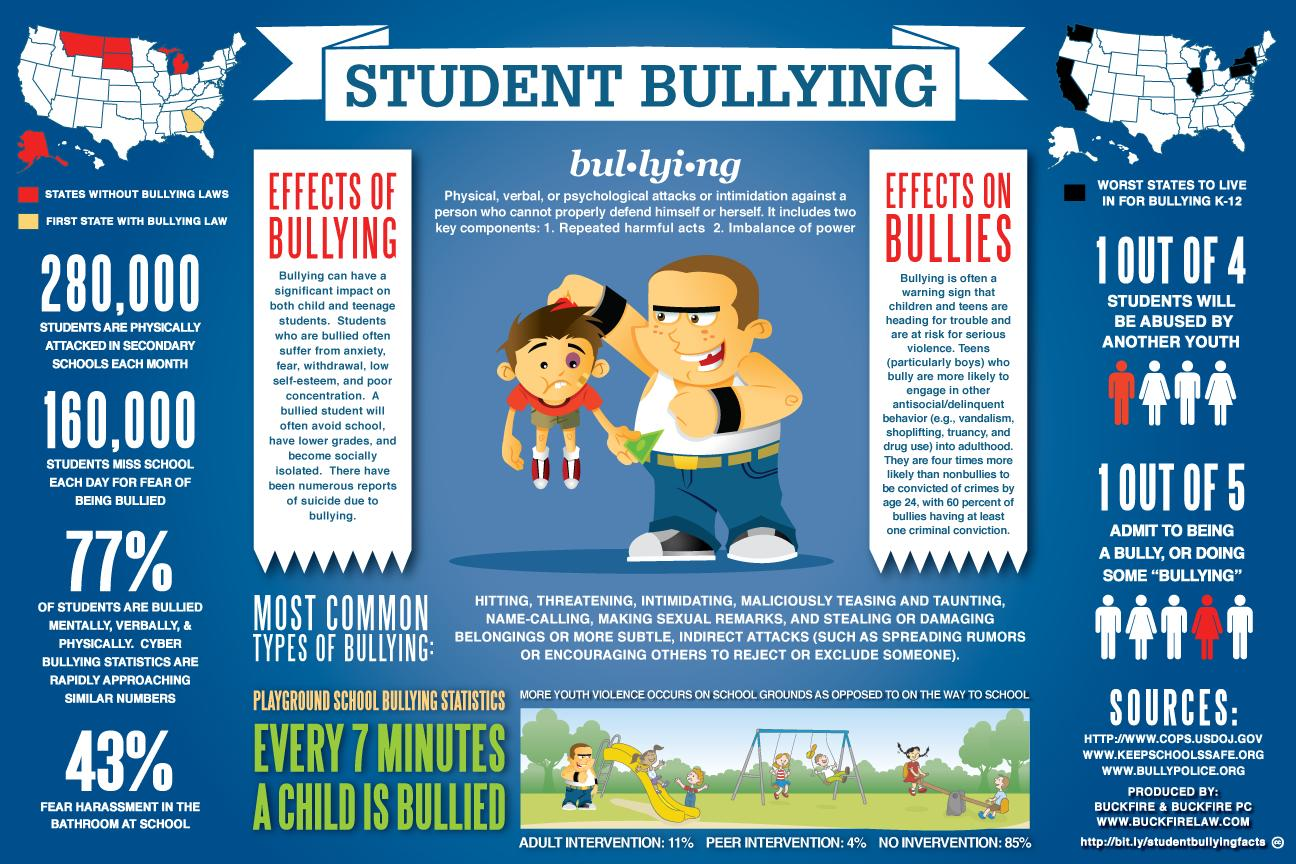Indicate a few pertinent items in this graphic. Georgia was the first state in the United States to pass bullying laws. According to estimates, approximately 160,000 students in America miss school every day due to the fear of being cyberbullied. In America, 43% of students fear harassment in the bathroom at school. In the United States, an estimated 280,000 students are physically attacked in secondary schools each month. 